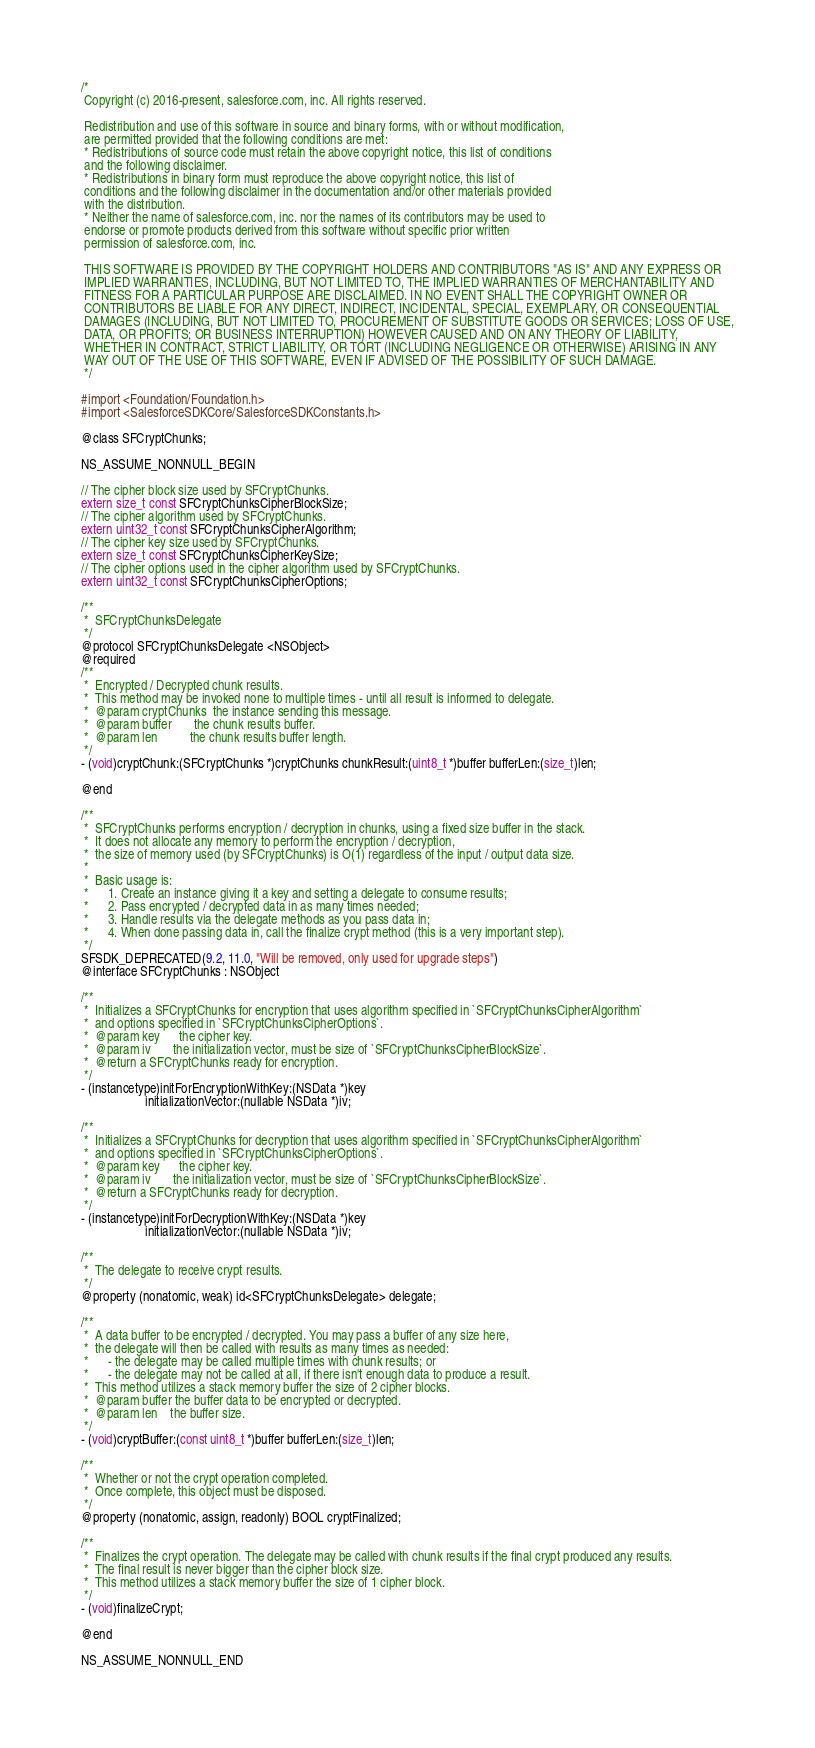Convert code to text. <code><loc_0><loc_0><loc_500><loc_500><_C_>/*
 Copyright (c) 2016-present, salesforce.com, inc. All rights reserved.
 
 Redistribution and use of this software in source and binary forms, with or without modification,
 are permitted provided that the following conditions are met:
 * Redistributions of source code must retain the above copyright notice, this list of conditions
 and the following disclaimer.
 * Redistributions in binary form must reproduce the above copyright notice, this list of
 conditions and the following disclaimer in the documentation and/or other materials provided
 with the distribution.
 * Neither the name of salesforce.com, inc. nor the names of its contributors may be used to
 endorse or promote products derived from this software without specific prior written
 permission of salesforce.com, inc.
 
 THIS SOFTWARE IS PROVIDED BY THE COPYRIGHT HOLDERS AND CONTRIBUTORS "AS IS" AND ANY EXPRESS OR
 IMPLIED WARRANTIES, INCLUDING, BUT NOT LIMITED TO, THE IMPLIED WARRANTIES OF MERCHANTABILITY AND
 FITNESS FOR A PARTICULAR PURPOSE ARE DISCLAIMED. IN NO EVENT SHALL THE COPYRIGHT OWNER OR
 CONTRIBUTORS BE LIABLE FOR ANY DIRECT, INDIRECT, INCIDENTAL, SPECIAL, EXEMPLARY, OR CONSEQUENTIAL
 DAMAGES (INCLUDING, BUT NOT LIMITED TO, PROCUREMENT OF SUBSTITUTE GOODS OR SERVICES; LOSS OF USE,
 DATA, OR PROFITS; OR BUSINESS INTERRUPTION) HOWEVER CAUSED AND ON ANY THEORY OF LIABILITY,
 WHETHER IN CONTRACT, STRICT LIABILITY, OR TORT (INCLUDING NEGLIGENCE OR OTHERWISE) ARISING IN ANY
 WAY OUT OF THE USE OF THIS SOFTWARE, EVEN IF ADVISED OF THE POSSIBILITY OF SUCH DAMAGE.
 */

#import <Foundation/Foundation.h>
#import <SalesforceSDKCore/SalesforceSDKConstants.h>

@class SFCryptChunks;

NS_ASSUME_NONNULL_BEGIN

// The cipher block size used by SFCryptChunks.
extern size_t const SFCryptChunksCipherBlockSize;
// The cipher algorithm used by SFCryptChunks.
extern uint32_t const SFCryptChunksCipherAlgorithm;
// The cipher key size used by SFCryptChunks.
extern size_t const SFCryptChunksCipherKeySize;
// The cipher options used in the cipher algorithm used by SFCryptChunks.
extern uint32_t const SFCryptChunksCipherOptions;

/**
 *  SFCryptChunksDelegate
 */
@protocol SFCryptChunksDelegate <NSObject>
@required
/**
 *  Encrypted / Decrypted chunk results. 
 *  This method may be invoked none to multiple times - until all result is informed to delegate.
 *  @param cryptChunks  the instance sending this message.
 *  @param buffer       the chunk results buffer.
 *  @param len          the chunk results buffer length.
 */
- (void)cryptChunk:(SFCryptChunks *)cryptChunks chunkResult:(uint8_t *)buffer bufferLen:(size_t)len;

@end

/**
 *  SFCryptChunks performs encryption / decryption in chunks, using a fixed size buffer in the stack.
 *  It does not allocate any memory to perform the encryption / decryption,
 *  the size of memory used (by SFCryptChunks) is O(1) regardless of the input / output data size.
 *  
 *  Basic usage is:
 *      1. Create an instance giving it a key and setting a delegate to consume results;
 *      2. Pass encrypted / decrypted data in as many times needed;
 *      3. Handle results via the delegate methods as you pass data in;
 *      4. When done passing data in, call the finalize crypt method (this is a very important step).
 */
SFSDK_DEPRECATED(9.2, 11.0, "Will be removed, only used for upgrade steps")
@interface SFCryptChunks : NSObject

/**
 *  Initializes a SFCryptChunks for encryption that uses algorithm specified in `SFCryptChunksCipherAlgorithm`
 *  and options specified in `SFCryptChunksCipherOptions`.
 *  @param key      the cipher key.
 *  @param iv       the initialization vector, must be size of `SFCryptChunksCipherBlockSize`.
 *  @return a SFCryptChunks ready for encryption.
 */
- (instancetype)initForEncryptionWithKey:(NSData *)key
                    initializationVector:(nullable NSData *)iv;

/**
 *  Initializes a SFCryptChunks for decryption that uses algorithm specified in `SFCryptChunksCipherAlgorithm`
 *  and options specified in `SFCryptChunksCipherOptions`.
 *  @param key      the cipher key.
 *  @param iv       the initialization vector, must be size of `SFCryptChunksCipherBlockSize`.
 *  @return a SFCryptChunks ready for decryption.
 */
- (instancetype)initForDecryptionWithKey:(NSData *)key
                    initializationVector:(nullable NSData *)iv;

/**
 *  The delegate to receive crypt results.
 */
@property (nonatomic, weak) id<SFCryptChunksDelegate> delegate;

/**
 *  A data buffer to be encrypted / decrypted. You may pass a buffer of any size here,
 *  the delegate will then be called with results as many times as needed:
 *      - the delegate may be called multiple times with chunk results; or
 *      - the delegate may not be called at all, if there isn't enough data to produce a result.
 *  This method utilizes a stack memory buffer the size of 2 cipher blocks.
 *  @param buffer the buffer data to be encrypted or decrypted.
 *  @param len    the buffer size.
 */
- (void)cryptBuffer:(const uint8_t *)buffer bufferLen:(size_t)len;

/**
 *  Whether or not the crypt operation completed. 
 *  Once complete, this object must be disposed.
 */
@property (nonatomic, assign, readonly) BOOL cryptFinalized;

/**
 *  Finalizes the crypt operation. The delegate may be called with chunk results if the final crypt produced any results.
 *  The final result is never bigger than the cipher block size.
 *  This method utilizes a stack memory buffer the size of 1 cipher block.
 */
- (void)finalizeCrypt;

@end

NS_ASSUME_NONNULL_END
</code> 